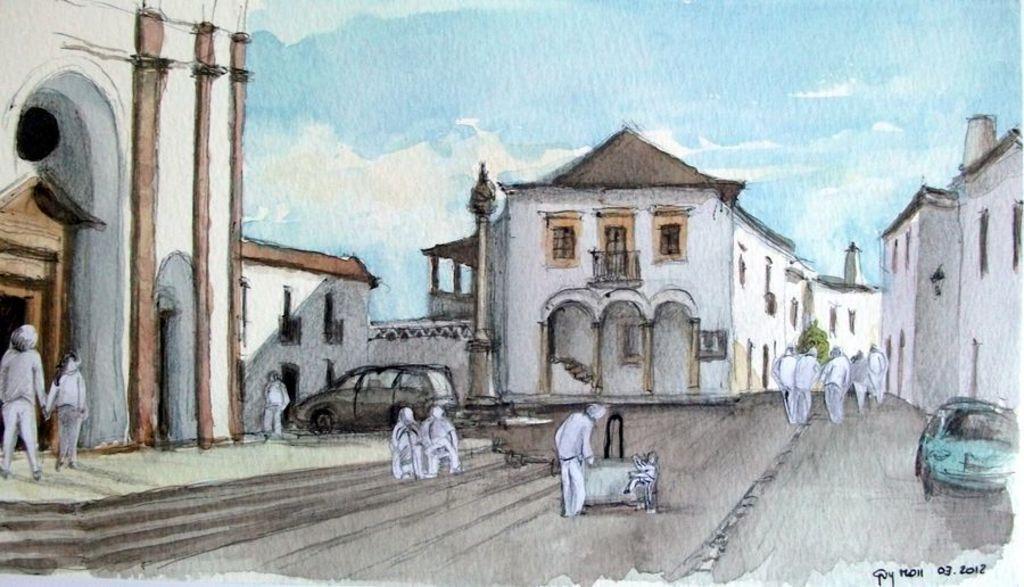How would you summarize this image in a sentence or two? In this image consists of a poster. In the middle there are houses. On the right there are some people, car and land. On the left there are some people, car, staircase. At the top there are sky and clouds. 